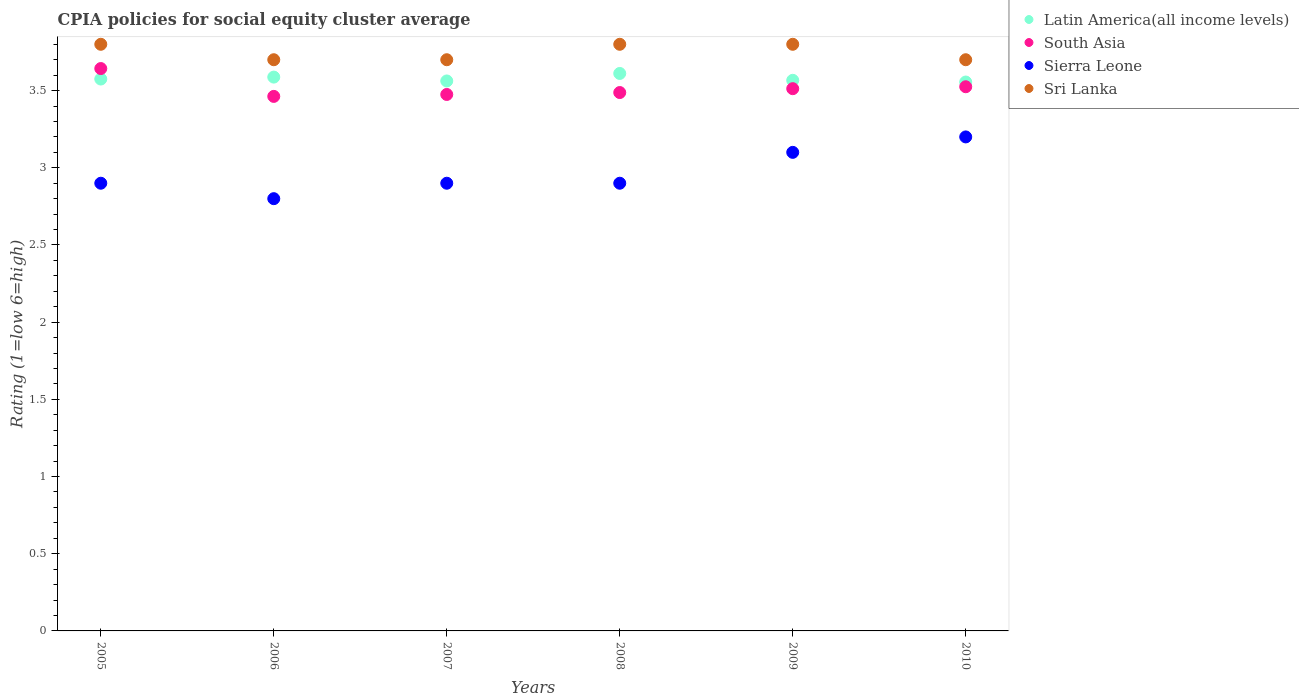How many different coloured dotlines are there?
Provide a succinct answer. 4. Is the number of dotlines equal to the number of legend labels?
Your response must be concise. Yes. What is the CPIA rating in Latin America(all income levels) in 2009?
Make the answer very short. 3.57. Across all years, what is the maximum CPIA rating in South Asia?
Provide a short and direct response. 3.64. Across all years, what is the minimum CPIA rating in Sierra Leone?
Provide a succinct answer. 2.8. In which year was the CPIA rating in South Asia minimum?
Provide a short and direct response. 2006. What is the difference between the CPIA rating in Latin America(all income levels) in 2007 and that in 2010?
Give a very brief answer. 0.01. What is the difference between the CPIA rating in South Asia in 2007 and the CPIA rating in Latin America(all income levels) in 2008?
Ensure brevity in your answer.  -0.14. What is the average CPIA rating in South Asia per year?
Keep it short and to the point. 3.52. In the year 2009, what is the difference between the CPIA rating in South Asia and CPIA rating in Latin America(all income levels)?
Your answer should be compact. -0.05. In how many years, is the CPIA rating in Sri Lanka greater than 2.4?
Give a very brief answer. 6. What is the ratio of the CPIA rating in Sri Lanka in 2006 to that in 2009?
Provide a succinct answer. 0.97. What is the difference between the highest and the second highest CPIA rating in Latin America(all income levels)?
Offer a very short reply. 0.02. What is the difference between the highest and the lowest CPIA rating in Sri Lanka?
Provide a short and direct response. 0.1. Is the sum of the CPIA rating in South Asia in 2006 and 2009 greater than the maximum CPIA rating in Latin America(all income levels) across all years?
Your response must be concise. Yes. Is it the case that in every year, the sum of the CPIA rating in Latin America(all income levels) and CPIA rating in Sierra Leone  is greater than the sum of CPIA rating in Sri Lanka and CPIA rating in South Asia?
Give a very brief answer. No. Is it the case that in every year, the sum of the CPIA rating in Latin America(all income levels) and CPIA rating in South Asia  is greater than the CPIA rating in Sierra Leone?
Your answer should be compact. Yes. Is the CPIA rating in South Asia strictly greater than the CPIA rating in Sierra Leone over the years?
Offer a very short reply. Yes. Is the CPIA rating in Sri Lanka strictly less than the CPIA rating in Sierra Leone over the years?
Make the answer very short. No. How many years are there in the graph?
Ensure brevity in your answer.  6. Does the graph contain any zero values?
Provide a succinct answer. No. Does the graph contain grids?
Ensure brevity in your answer.  No. How are the legend labels stacked?
Provide a short and direct response. Vertical. What is the title of the graph?
Make the answer very short. CPIA policies for social equity cluster average. Does "Libya" appear as one of the legend labels in the graph?
Offer a terse response. No. What is the label or title of the X-axis?
Offer a terse response. Years. What is the label or title of the Y-axis?
Provide a succinct answer. Rating (1=low 6=high). What is the Rating (1=low 6=high) of Latin America(all income levels) in 2005?
Make the answer very short. 3.58. What is the Rating (1=low 6=high) of South Asia in 2005?
Offer a very short reply. 3.64. What is the Rating (1=low 6=high) of Sri Lanka in 2005?
Your answer should be compact. 3.8. What is the Rating (1=low 6=high) of Latin America(all income levels) in 2006?
Give a very brief answer. 3.59. What is the Rating (1=low 6=high) in South Asia in 2006?
Ensure brevity in your answer.  3.46. What is the Rating (1=low 6=high) in Sri Lanka in 2006?
Provide a short and direct response. 3.7. What is the Rating (1=low 6=high) of Latin America(all income levels) in 2007?
Offer a very short reply. 3.56. What is the Rating (1=low 6=high) of South Asia in 2007?
Your answer should be very brief. 3.48. What is the Rating (1=low 6=high) of Sierra Leone in 2007?
Make the answer very short. 2.9. What is the Rating (1=low 6=high) of Latin America(all income levels) in 2008?
Keep it short and to the point. 3.61. What is the Rating (1=low 6=high) of South Asia in 2008?
Make the answer very short. 3.49. What is the Rating (1=low 6=high) in Sierra Leone in 2008?
Offer a very short reply. 2.9. What is the Rating (1=low 6=high) of Sri Lanka in 2008?
Make the answer very short. 3.8. What is the Rating (1=low 6=high) in Latin America(all income levels) in 2009?
Your answer should be compact. 3.57. What is the Rating (1=low 6=high) in South Asia in 2009?
Your answer should be compact. 3.51. What is the Rating (1=low 6=high) of Sierra Leone in 2009?
Your answer should be compact. 3.1. What is the Rating (1=low 6=high) in Sri Lanka in 2009?
Your answer should be compact. 3.8. What is the Rating (1=low 6=high) of Latin America(all income levels) in 2010?
Give a very brief answer. 3.56. What is the Rating (1=low 6=high) of South Asia in 2010?
Provide a short and direct response. 3.52. What is the Rating (1=low 6=high) of Sri Lanka in 2010?
Provide a short and direct response. 3.7. Across all years, what is the maximum Rating (1=low 6=high) of Latin America(all income levels)?
Give a very brief answer. 3.61. Across all years, what is the maximum Rating (1=low 6=high) of South Asia?
Offer a very short reply. 3.64. Across all years, what is the minimum Rating (1=low 6=high) of Latin America(all income levels)?
Provide a short and direct response. 3.56. Across all years, what is the minimum Rating (1=low 6=high) of South Asia?
Your answer should be very brief. 3.46. Across all years, what is the minimum Rating (1=low 6=high) in Sierra Leone?
Provide a short and direct response. 2.8. What is the total Rating (1=low 6=high) in Latin America(all income levels) in the graph?
Keep it short and to the point. 21.46. What is the total Rating (1=low 6=high) in South Asia in the graph?
Make the answer very short. 21.11. What is the total Rating (1=low 6=high) in Sri Lanka in the graph?
Keep it short and to the point. 22.5. What is the difference between the Rating (1=low 6=high) of Latin America(all income levels) in 2005 and that in 2006?
Provide a succinct answer. -0.01. What is the difference between the Rating (1=low 6=high) in South Asia in 2005 and that in 2006?
Make the answer very short. 0.18. What is the difference between the Rating (1=low 6=high) in Sri Lanka in 2005 and that in 2006?
Offer a terse response. 0.1. What is the difference between the Rating (1=low 6=high) of Latin America(all income levels) in 2005 and that in 2007?
Offer a terse response. 0.01. What is the difference between the Rating (1=low 6=high) in South Asia in 2005 and that in 2007?
Provide a short and direct response. 0.17. What is the difference between the Rating (1=low 6=high) in Sierra Leone in 2005 and that in 2007?
Offer a terse response. 0. What is the difference between the Rating (1=low 6=high) in Latin America(all income levels) in 2005 and that in 2008?
Your answer should be very brief. -0.04. What is the difference between the Rating (1=low 6=high) of South Asia in 2005 and that in 2008?
Give a very brief answer. 0.16. What is the difference between the Rating (1=low 6=high) in Sierra Leone in 2005 and that in 2008?
Provide a short and direct response. 0. What is the difference between the Rating (1=low 6=high) of Latin America(all income levels) in 2005 and that in 2009?
Offer a very short reply. 0.01. What is the difference between the Rating (1=low 6=high) of South Asia in 2005 and that in 2009?
Offer a terse response. 0.13. What is the difference between the Rating (1=low 6=high) in Latin America(all income levels) in 2005 and that in 2010?
Give a very brief answer. 0.02. What is the difference between the Rating (1=low 6=high) of South Asia in 2005 and that in 2010?
Make the answer very short. 0.12. What is the difference between the Rating (1=low 6=high) in Sri Lanka in 2005 and that in 2010?
Make the answer very short. 0.1. What is the difference between the Rating (1=low 6=high) of Latin America(all income levels) in 2006 and that in 2007?
Offer a terse response. 0.03. What is the difference between the Rating (1=low 6=high) of South Asia in 2006 and that in 2007?
Ensure brevity in your answer.  -0.01. What is the difference between the Rating (1=low 6=high) in Latin America(all income levels) in 2006 and that in 2008?
Provide a short and direct response. -0.02. What is the difference between the Rating (1=low 6=high) in South Asia in 2006 and that in 2008?
Give a very brief answer. -0.03. What is the difference between the Rating (1=low 6=high) in Sierra Leone in 2006 and that in 2008?
Give a very brief answer. -0.1. What is the difference between the Rating (1=low 6=high) of Sri Lanka in 2006 and that in 2008?
Ensure brevity in your answer.  -0.1. What is the difference between the Rating (1=low 6=high) in Latin America(all income levels) in 2006 and that in 2009?
Offer a very short reply. 0.02. What is the difference between the Rating (1=low 6=high) in Sierra Leone in 2006 and that in 2009?
Offer a very short reply. -0.3. What is the difference between the Rating (1=low 6=high) in Latin America(all income levels) in 2006 and that in 2010?
Your answer should be very brief. 0.03. What is the difference between the Rating (1=low 6=high) in South Asia in 2006 and that in 2010?
Ensure brevity in your answer.  -0.06. What is the difference between the Rating (1=low 6=high) of Sierra Leone in 2006 and that in 2010?
Offer a very short reply. -0.4. What is the difference between the Rating (1=low 6=high) in Sri Lanka in 2006 and that in 2010?
Make the answer very short. 0. What is the difference between the Rating (1=low 6=high) in Latin America(all income levels) in 2007 and that in 2008?
Ensure brevity in your answer.  -0.05. What is the difference between the Rating (1=low 6=high) of South Asia in 2007 and that in 2008?
Your response must be concise. -0.01. What is the difference between the Rating (1=low 6=high) in Sierra Leone in 2007 and that in 2008?
Make the answer very short. 0. What is the difference between the Rating (1=low 6=high) in Latin America(all income levels) in 2007 and that in 2009?
Provide a succinct answer. -0. What is the difference between the Rating (1=low 6=high) of South Asia in 2007 and that in 2009?
Your answer should be very brief. -0.04. What is the difference between the Rating (1=low 6=high) of Latin America(all income levels) in 2007 and that in 2010?
Keep it short and to the point. 0.01. What is the difference between the Rating (1=low 6=high) in Latin America(all income levels) in 2008 and that in 2009?
Your answer should be compact. 0.04. What is the difference between the Rating (1=low 6=high) of South Asia in 2008 and that in 2009?
Keep it short and to the point. -0.03. What is the difference between the Rating (1=low 6=high) of Latin America(all income levels) in 2008 and that in 2010?
Your answer should be very brief. 0.06. What is the difference between the Rating (1=low 6=high) in South Asia in 2008 and that in 2010?
Provide a succinct answer. -0.04. What is the difference between the Rating (1=low 6=high) of Sierra Leone in 2008 and that in 2010?
Your answer should be compact. -0.3. What is the difference between the Rating (1=low 6=high) of Latin America(all income levels) in 2009 and that in 2010?
Offer a terse response. 0.01. What is the difference between the Rating (1=low 6=high) in South Asia in 2009 and that in 2010?
Ensure brevity in your answer.  -0.01. What is the difference between the Rating (1=low 6=high) of Sierra Leone in 2009 and that in 2010?
Offer a very short reply. -0.1. What is the difference between the Rating (1=low 6=high) in Latin America(all income levels) in 2005 and the Rating (1=low 6=high) in South Asia in 2006?
Make the answer very short. 0.11. What is the difference between the Rating (1=low 6=high) in Latin America(all income levels) in 2005 and the Rating (1=low 6=high) in Sierra Leone in 2006?
Your answer should be very brief. 0.78. What is the difference between the Rating (1=low 6=high) of Latin America(all income levels) in 2005 and the Rating (1=low 6=high) of Sri Lanka in 2006?
Offer a very short reply. -0.12. What is the difference between the Rating (1=low 6=high) in South Asia in 2005 and the Rating (1=low 6=high) in Sierra Leone in 2006?
Offer a very short reply. 0.84. What is the difference between the Rating (1=low 6=high) of South Asia in 2005 and the Rating (1=low 6=high) of Sri Lanka in 2006?
Your answer should be very brief. -0.06. What is the difference between the Rating (1=low 6=high) in Latin America(all income levels) in 2005 and the Rating (1=low 6=high) in South Asia in 2007?
Provide a succinct answer. 0.1. What is the difference between the Rating (1=low 6=high) of Latin America(all income levels) in 2005 and the Rating (1=low 6=high) of Sierra Leone in 2007?
Your answer should be very brief. 0.68. What is the difference between the Rating (1=low 6=high) of Latin America(all income levels) in 2005 and the Rating (1=low 6=high) of Sri Lanka in 2007?
Give a very brief answer. -0.12. What is the difference between the Rating (1=low 6=high) of South Asia in 2005 and the Rating (1=low 6=high) of Sierra Leone in 2007?
Make the answer very short. 0.74. What is the difference between the Rating (1=low 6=high) in South Asia in 2005 and the Rating (1=low 6=high) in Sri Lanka in 2007?
Provide a short and direct response. -0.06. What is the difference between the Rating (1=low 6=high) in Sierra Leone in 2005 and the Rating (1=low 6=high) in Sri Lanka in 2007?
Offer a very short reply. -0.8. What is the difference between the Rating (1=low 6=high) in Latin America(all income levels) in 2005 and the Rating (1=low 6=high) in South Asia in 2008?
Offer a very short reply. 0.09. What is the difference between the Rating (1=low 6=high) of Latin America(all income levels) in 2005 and the Rating (1=low 6=high) of Sierra Leone in 2008?
Keep it short and to the point. 0.68. What is the difference between the Rating (1=low 6=high) of Latin America(all income levels) in 2005 and the Rating (1=low 6=high) of Sri Lanka in 2008?
Make the answer very short. -0.23. What is the difference between the Rating (1=low 6=high) of South Asia in 2005 and the Rating (1=low 6=high) of Sierra Leone in 2008?
Offer a terse response. 0.74. What is the difference between the Rating (1=low 6=high) in South Asia in 2005 and the Rating (1=low 6=high) in Sri Lanka in 2008?
Your answer should be compact. -0.16. What is the difference between the Rating (1=low 6=high) in Latin America(all income levels) in 2005 and the Rating (1=low 6=high) in South Asia in 2009?
Your answer should be very brief. 0.06. What is the difference between the Rating (1=low 6=high) of Latin America(all income levels) in 2005 and the Rating (1=low 6=high) of Sierra Leone in 2009?
Make the answer very short. 0.47. What is the difference between the Rating (1=low 6=high) in Latin America(all income levels) in 2005 and the Rating (1=low 6=high) in Sri Lanka in 2009?
Provide a succinct answer. -0.23. What is the difference between the Rating (1=low 6=high) in South Asia in 2005 and the Rating (1=low 6=high) in Sierra Leone in 2009?
Keep it short and to the point. 0.54. What is the difference between the Rating (1=low 6=high) of South Asia in 2005 and the Rating (1=low 6=high) of Sri Lanka in 2009?
Keep it short and to the point. -0.16. What is the difference between the Rating (1=low 6=high) of Latin America(all income levels) in 2005 and the Rating (1=low 6=high) of South Asia in 2010?
Your answer should be very brief. 0.05. What is the difference between the Rating (1=low 6=high) in Latin America(all income levels) in 2005 and the Rating (1=low 6=high) in Sierra Leone in 2010?
Offer a very short reply. 0.38. What is the difference between the Rating (1=low 6=high) in Latin America(all income levels) in 2005 and the Rating (1=low 6=high) in Sri Lanka in 2010?
Offer a very short reply. -0.12. What is the difference between the Rating (1=low 6=high) of South Asia in 2005 and the Rating (1=low 6=high) of Sierra Leone in 2010?
Offer a very short reply. 0.44. What is the difference between the Rating (1=low 6=high) of South Asia in 2005 and the Rating (1=low 6=high) of Sri Lanka in 2010?
Your answer should be compact. -0.06. What is the difference between the Rating (1=low 6=high) of Sierra Leone in 2005 and the Rating (1=low 6=high) of Sri Lanka in 2010?
Give a very brief answer. -0.8. What is the difference between the Rating (1=low 6=high) of Latin America(all income levels) in 2006 and the Rating (1=low 6=high) of South Asia in 2007?
Your answer should be compact. 0.11. What is the difference between the Rating (1=low 6=high) of Latin America(all income levels) in 2006 and the Rating (1=low 6=high) of Sierra Leone in 2007?
Your answer should be very brief. 0.69. What is the difference between the Rating (1=low 6=high) of Latin America(all income levels) in 2006 and the Rating (1=low 6=high) of Sri Lanka in 2007?
Offer a very short reply. -0.11. What is the difference between the Rating (1=low 6=high) in South Asia in 2006 and the Rating (1=low 6=high) in Sierra Leone in 2007?
Your answer should be compact. 0.56. What is the difference between the Rating (1=low 6=high) of South Asia in 2006 and the Rating (1=low 6=high) of Sri Lanka in 2007?
Keep it short and to the point. -0.24. What is the difference between the Rating (1=low 6=high) in Sierra Leone in 2006 and the Rating (1=low 6=high) in Sri Lanka in 2007?
Give a very brief answer. -0.9. What is the difference between the Rating (1=low 6=high) in Latin America(all income levels) in 2006 and the Rating (1=low 6=high) in South Asia in 2008?
Ensure brevity in your answer.  0.1. What is the difference between the Rating (1=low 6=high) in Latin America(all income levels) in 2006 and the Rating (1=low 6=high) in Sierra Leone in 2008?
Give a very brief answer. 0.69. What is the difference between the Rating (1=low 6=high) of Latin America(all income levels) in 2006 and the Rating (1=low 6=high) of Sri Lanka in 2008?
Offer a terse response. -0.21. What is the difference between the Rating (1=low 6=high) of South Asia in 2006 and the Rating (1=low 6=high) of Sierra Leone in 2008?
Make the answer very short. 0.56. What is the difference between the Rating (1=low 6=high) in South Asia in 2006 and the Rating (1=low 6=high) in Sri Lanka in 2008?
Provide a short and direct response. -0.34. What is the difference between the Rating (1=low 6=high) in Sierra Leone in 2006 and the Rating (1=low 6=high) in Sri Lanka in 2008?
Your answer should be compact. -1. What is the difference between the Rating (1=low 6=high) in Latin America(all income levels) in 2006 and the Rating (1=low 6=high) in South Asia in 2009?
Your answer should be very brief. 0.07. What is the difference between the Rating (1=low 6=high) of Latin America(all income levels) in 2006 and the Rating (1=low 6=high) of Sierra Leone in 2009?
Provide a succinct answer. 0.49. What is the difference between the Rating (1=low 6=high) in Latin America(all income levels) in 2006 and the Rating (1=low 6=high) in Sri Lanka in 2009?
Give a very brief answer. -0.21. What is the difference between the Rating (1=low 6=high) of South Asia in 2006 and the Rating (1=low 6=high) of Sierra Leone in 2009?
Your answer should be very brief. 0.36. What is the difference between the Rating (1=low 6=high) in South Asia in 2006 and the Rating (1=low 6=high) in Sri Lanka in 2009?
Provide a short and direct response. -0.34. What is the difference between the Rating (1=low 6=high) of Sierra Leone in 2006 and the Rating (1=low 6=high) of Sri Lanka in 2009?
Your response must be concise. -1. What is the difference between the Rating (1=low 6=high) in Latin America(all income levels) in 2006 and the Rating (1=low 6=high) in South Asia in 2010?
Your response must be concise. 0.06. What is the difference between the Rating (1=low 6=high) in Latin America(all income levels) in 2006 and the Rating (1=low 6=high) in Sierra Leone in 2010?
Offer a very short reply. 0.39. What is the difference between the Rating (1=low 6=high) of Latin America(all income levels) in 2006 and the Rating (1=low 6=high) of Sri Lanka in 2010?
Your answer should be very brief. -0.11. What is the difference between the Rating (1=low 6=high) of South Asia in 2006 and the Rating (1=low 6=high) of Sierra Leone in 2010?
Give a very brief answer. 0.26. What is the difference between the Rating (1=low 6=high) of South Asia in 2006 and the Rating (1=low 6=high) of Sri Lanka in 2010?
Your response must be concise. -0.24. What is the difference between the Rating (1=low 6=high) in Latin America(all income levels) in 2007 and the Rating (1=low 6=high) in South Asia in 2008?
Offer a terse response. 0.07. What is the difference between the Rating (1=low 6=high) of Latin America(all income levels) in 2007 and the Rating (1=low 6=high) of Sierra Leone in 2008?
Your answer should be very brief. 0.66. What is the difference between the Rating (1=low 6=high) of Latin America(all income levels) in 2007 and the Rating (1=low 6=high) of Sri Lanka in 2008?
Your response must be concise. -0.24. What is the difference between the Rating (1=low 6=high) in South Asia in 2007 and the Rating (1=low 6=high) in Sierra Leone in 2008?
Offer a terse response. 0.57. What is the difference between the Rating (1=low 6=high) of South Asia in 2007 and the Rating (1=low 6=high) of Sri Lanka in 2008?
Ensure brevity in your answer.  -0.33. What is the difference between the Rating (1=low 6=high) of Sierra Leone in 2007 and the Rating (1=low 6=high) of Sri Lanka in 2008?
Ensure brevity in your answer.  -0.9. What is the difference between the Rating (1=low 6=high) of Latin America(all income levels) in 2007 and the Rating (1=low 6=high) of South Asia in 2009?
Offer a terse response. 0.05. What is the difference between the Rating (1=low 6=high) in Latin America(all income levels) in 2007 and the Rating (1=low 6=high) in Sierra Leone in 2009?
Your answer should be compact. 0.46. What is the difference between the Rating (1=low 6=high) in Latin America(all income levels) in 2007 and the Rating (1=low 6=high) in Sri Lanka in 2009?
Provide a short and direct response. -0.24. What is the difference between the Rating (1=low 6=high) in South Asia in 2007 and the Rating (1=low 6=high) in Sierra Leone in 2009?
Ensure brevity in your answer.  0.38. What is the difference between the Rating (1=low 6=high) in South Asia in 2007 and the Rating (1=low 6=high) in Sri Lanka in 2009?
Provide a succinct answer. -0.33. What is the difference between the Rating (1=low 6=high) in Sierra Leone in 2007 and the Rating (1=low 6=high) in Sri Lanka in 2009?
Make the answer very short. -0.9. What is the difference between the Rating (1=low 6=high) of Latin America(all income levels) in 2007 and the Rating (1=low 6=high) of South Asia in 2010?
Provide a short and direct response. 0.04. What is the difference between the Rating (1=low 6=high) of Latin America(all income levels) in 2007 and the Rating (1=low 6=high) of Sierra Leone in 2010?
Your response must be concise. 0.36. What is the difference between the Rating (1=low 6=high) in Latin America(all income levels) in 2007 and the Rating (1=low 6=high) in Sri Lanka in 2010?
Ensure brevity in your answer.  -0.14. What is the difference between the Rating (1=low 6=high) in South Asia in 2007 and the Rating (1=low 6=high) in Sierra Leone in 2010?
Your answer should be compact. 0.28. What is the difference between the Rating (1=low 6=high) of South Asia in 2007 and the Rating (1=low 6=high) of Sri Lanka in 2010?
Provide a short and direct response. -0.23. What is the difference between the Rating (1=low 6=high) of Sierra Leone in 2007 and the Rating (1=low 6=high) of Sri Lanka in 2010?
Give a very brief answer. -0.8. What is the difference between the Rating (1=low 6=high) in Latin America(all income levels) in 2008 and the Rating (1=low 6=high) in South Asia in 2009?
Give a very brief answer. 0.1. What is the difference between the Rating (1=low 6=high) in Latin America(all income levels) in 2008 and the Rating (1=low 6=high) in Sierra Leone in 2009?
Offer a terse response. 0.51. What is the difference between the Rating (1=low 6=high) of Latin America(all income levels) in 2008 and the Rating (1=low 6=high) of Sri Lanka in 2009?
Ensure brevity in your answer.  -0.19. What is the difference between the Rating (1=low 6=high) of South Asia in 2008 and the Rating (1=low 6=high) of Sierra Leone in 2009?
Your answer should be very brief. 0.39. What is the difference between the Rating (1=low 6=high) of South Asia in 2008 and the Rating (1=low 6=high) of Sri Lanka in 2009?
Your answer should be compact. -0.31. What is the difference between the Rating (1=low 6=high) of Sierra Leone in 2008 and the Rating (1=low 6=high) of Sri Lanka in 2009?
Ensure brevity in your answer.  -0.9. What is the difference between the Rating (1=low 6=high) of Latin America(all income levels) in 2008 and the Rating (1=low 6=high) of South Asia in 2010?
Your answer should be very brief. 0.09. What is the difference between the Rating (1=low 6=high) in Latin America(all income levels) in 2008 and the Rating (1=low 6=high) in Sierra Leone in 2010?
Give a very brief answer. 0.41. What is the difference between the Rating (1=low 6=high) of Latin America(all income levels) in 2008 and the Rating (1=low 6=high) of Sri Lanka in 2010?
Your answer should be compact. -0.09. What is the difference between the Rating (1=low 6=high) in South Asia in 2008 and the Rating (1=low 6=high) in Sierra Leone in 2010?
Your answer should be very brief. 0.29. What is the difference between the Rating (1=low 6=high) in South Asia in 2008 and the Rating (1=low 6=high) in Sri Lanka in 2010?
Offer a very short reply. -0.21. What is the difference between the Rating (1=low 6=high) of Latin America(all income levels) in 2009 and the Rating (1=low 6=high) of South Asia in 2010?
Your response must be concise. 0.04. What is the difference between the Rating (1=low 6=high) of Latin America(all income levels) in 2009 and the Rating (1=low 6=high) of Sierra Leone in 2010?
Offer a very short reply. 0.37. What is the difference between the Rating (1=low 6=high) of Latin America(all income levels) in 2009 and the Rating (1=low 6=high) of Sri Lanka in 2010?
Offer a terse response. -0.13. What is the difference between the Rating (1=low 6=high) in South Asia in 2009 and the Rating (1=low 6=high) in Sierra Leone in 2010?
Give a very brief answer. 0.31. What is the difference between the Rating (1=low 6=high) of South Asia in 2009 and the Rating (1=low 6=high) of Sri Lanka in 2010?
Ensure brevity in your answer.  -0.19. What is the average Rating (1=low 6=high) of Latin America(all income levels) per year?
Offer a very short reply. 3.58. What is the average Rating (1=low 6=high) of South Asia per year?
Keep it short and to the point. 3.52. What is the average Rating (1=low 6=high) in Sierra Leone per year?
Provide a short and direct response. 2.97. What is the average Rating (1=low 6=high) in Sri Lanka per year?
Make the answer very short. 3.75. In the year 2005, what is the difference between the Rating (1=low 6=high) of Latin America(all income levels) and Rating (1=low 6=high) of South Asia?
Give a very brief answer. -0.07. In the year 2005, what is the difference between the Rating (1=low 6=high) of Latin America(all income levels) and Rating (1=low 6=high) of Sierra Leone?
Your answer should be very brief. 0.68. In the year 2005, what is the difference between the Rating (1=low 6=high) of Latin America(all income levels) and Rating (1=low 6=high) of Sri Lanka?
Keep it short and to the point. -0.23. In the year 2005, what is the difference between the Rating (1=low 6=high) of South Asia and Rating (1=low 6=high) of Sierra Leone?
Your response must be concise. 0.74. In the year 2005, what is the difference between the Rating (1=low 6=high) of South Asia and Rating (1=low 6=high) of Sri Lanka?
Provide a succinct answer. -0.16. In the year 2006, what is the difference between the Rating (1=low 6=high) in Latin America(all income levels) and Rating (1=low 6=high) in South Asia?
Give a very brief answer. 0.12. In the year 2006, what is the difference between the Rating (1=low 6=high) in Latin America(all income levels) and Rating (1=low 6=high) in Sierra Leone?
Make the answer very short. 0.79. In the year 2006, what is the difference between the Rating (1=low 6=high) of Latin America(all income levels) and Rating (1=low 6=high) of Sri Lanka?
Offer a terse response. -0.11. In the year 2006, what is the difference between the Rating (1=low 6=high) in South Asia and Rating (1=low 6=high) in Sierra Leone?
Provide a short and direct response. 0.66. In the year 2006, what is the difference between the Rating (1=low 6=high) in South Asia and Rating (1=low 6=high) in Sri Lanka?
Your response must be concise. -0.24. In the year 2007, what is the difference between the Rating (1=low 6=high) in Latin America(all income levels) and Rating (1=low 6=high) in South Asia?
Keep it short and to the point. 0.09. In the year 2007, what is the difference between the Rating (1=low 6=high) of Latin America(all income levels) and Rating (1=low 6=high) of Sierra Leone?
Make the answer very short. 0.66. In the year 2007, what is the difference between the Rating (1=low 6=high) of Latin America(all income levels) and Rating (1=low 6=high) of Sri Lanka?
Provide a short and direct response. -0.14. In the year 2007, what is the difference between the Rating (1=low 6=high) of South Asia and Rating (1=low 6=high) of Sierra Leone?
Make the answer very short. 0.57. In the year 2007, what is the difference between the Rating (1=low 6=high) of South Asia and Rating (1=low 6=high) of Sri Lanka?
Your response must be concise. -0.23. In the year 2007, what is the difference between the Rating (1=low 6=high) of Sierra Leone and Rating (1=low 6=high) of Sri Lanka?
Offer a terse response. -0.8. In the year 2008, what is the difference between the Rating (1=low 6=high) of Latin America(all income levels) and Rating (1=low 6=high) of South Asia?
Offer a very short reply. 0.12. In the year 2008, what is the difference between the Rating (1=low 6=high) in Latin America(all income levels) and Rating (1=low 6=high) in Sierra Leone?
Your answer should be very brief. 0.71. In the year 2008, what is the difference between the Rating (1=low 6=high) of Latin America(all income levels) and Rating (1=low 6=high) of Sri Lanka?
Your response must be concise. -0.19. In the year 2008, what is the difference between the Rating (1=low 6=high) in South Asia and Rating (1=low 6=high) in Sierra Leone?
Keep it short and to the point. 0.59. In the year 2008, what is the difference between the Rating (1=low 6=high) of South Asia and Rating (1=low 6=high) of Sri Lanka?
Your response must be concise. -0.31. In the year 2008, what is the difference between the Rating (1=low 6=high) of Sierra Leone and Rating (1=low 6=high) of Sri Lanka?
Your answer should be compact. -0.9. In the year 2009, what is the difference between the Rating (1=low 6=high) of Latin America(all income levels) and Rating (1=low 6=high) of South Asia?
Offer a terse response. 0.05. In the year 2009, what is the difference between the Rating (1=low 6=high) of Latin America(all income levels) and Rating (1=low 6=high) of Sierra Leone?
Offer a very short reply. 0.47. In the year 2009, what is the difference between the Rating (1=low 6=high) of Latin America(all income levels) and Rating (1=low 6=high) of Sri Lanka?
Offer a very short reply. -0.23. In the year 2009, what is the difference between the Rating (1=low 6=high) of South Asia and Rating (1=low 6=high) of Sierra Leone?
Give a very brief answer. 0.41. In the year 2009, what is the difference between the Rating (1=low 6=high) of South Asia and Rating (1=low 6=high) of Sri Lanka?
Give a very brief answer. -0.29. In the year 2010, what is the difference between the Rating (1=low 6=high) of Latin America(all income levels) and Rating (1=low 6=high) of South Asia?
Keep it short and to the point. 0.03. In the year 2010, what is the difference between the Rating (1=low 6=high) of Latin America(all income levels) and Rating (1=low 6=high) of Sierra Leone?
Offer a very short reply. 0.36. In the year 2010, what is the difference between the Rating (1=low 6=high) of Latin America(all income levels) and Rating (1=low 6=high) of Sri Lanka?
Offer a very short reply. -0.14. In the year 2010, what is the difference between the Rating (1=low 6=high) in South Asia and Rating (1=low 6=high) in Sierra Leone?
Offer a very short reply. 0.33. In the year 2010, what is the difference between the Rating (1=low 6=high) of South Asia and Rating (1=low 6=high) of Sri Lanka?
Offer a terse response. -0.17. What is the ratio of the Rating (1=low 6=high) in South Asia in 2005 to that in 2006?
Ensure brevity in your answer.  1.05. What is the ratio of the Rating (1=low 6=high) of Sierra Leone in 2005 to that in 2006?
Keep it short and to the point. 1.04. What is the ratio of the Rating (1=low 6=high) of South Asia in 2005 to that in 2007?
Your answer should be compact. 1.05. What is the ratio of the Rating (1=low 6=high) of South Asia in 2005 to that in 2008?
Your answer should be compact. 1.04. What is the ratio of the Rating (1=low 6=high) of Sierra Leone in 2005 to that in 2008?
Make the answer very short. 1. What is the ratio of the Rating (1=low 6=high) of Sri Lanka in 2005 to that in 2008?
Your response must be concise. 1. What is the ratio of the Rating (1=low 6=high) in South Asia in 2005 to that in 2009?
Provide a short and direct response. 1.04. What is the ratio of the Rating (1=low 6=high) of Sierra Leone in 2005 to that in 2009?
Your answer should be very brief. 0.94. What is the ratio of the Rating (1=low 6=high) of South Asia in 2005 to that in 2010?
Ensure brevity in your answer.  1.03. What is the ratio of the Rating (1=low 6=high) of Sierra Leone in 2005 to that in 2010?
Offer a very short reply. 0.91. What is the ratio of the Rating (1=low 6=high) of South Asia in 2006 to that in 2007?
Give a very brief answer. 1. What is the ratio of the Rating (1=low 6=high) in Sierra Leone in 2006 to that in 2007?
Keep it short and to the point. 0.97. What is the ratio of the Rating (1=low 6=high) of Sri Lanka in 2006 to that in 2007?
Ensure brevity in your answer.  1. What is the ratio of the Rating (1=low 6=high) in Latin America(all income levels) in 2006 to that in 2008?
Make the answer very short. 0.99. What is the ratio of the Rating (1=low 6=high) of South Asia in 2006 to that in 2008?
Make the answer very short. 0.99. What is the ratio of the Rating (1=low 6=high) of Sierra Leone in 2006 to that in 2008?
Your answer should be very brief. 0.97. What is the ratio of the Rating (1=low 6=high) in Sri Lanka in 2006 to that in 2008?
Your answer should be very brief. 0.97. What is the ratio of the Rating (1=low 6=high) in South Asia in 2006 to that in 2009?
Your answer should be very brief. 0.99. What is the ratio of the Rating (1=low 6=high) in Sierra Leone in 2006 to that in 2009?
Keep it short and to the point. 0.9. What is the ratio of the Rating (1=low 6=high) in Sri Lanka in 2006 to that in 2009?
Your response must be concise. 0.97. What is the ratio of the Rating (1=low 6=high) of Latin America(all income levels) in 2006 to that in 2010?
Your response must be concise. 1.01. What is the ratio of the Rating (1=low 6=high) of South Asia in 2006 to that in 2010?
Your answer should be compact. 0.98. What is the ratio of the Rating (1=low 6=high) in Sierra Leone in 2006 to that in 2010?
Provide a short and direct response. 0.88. What is the ratio of the Rating (1=low 6=high) in Sri Lanka in 2006 to that in 2010?
Make the answer very short. 1. What is the ratio of the Rating (1=low 6=high) in Latin America(all income levels) in 2007 to that in 2008?
Provide a short and direct response. 0.99. What is the ratio of the Rating (1=low 6=high) in South Asia in 2007 to that in 2008?
Offer a very short reply. 1. What is the ratio of the Rating (1=low 6=high) in Sierra Leone in 2007 to that in 2008?
Your answer should be compact. 1. What is the ratio of the Rating (1=low 6=high) in Sri Lanka in 2007 to that in 2008?
Offer a very short reply. 0.97. What is the ratio of the Rating (1=low 6=high) in Latin America(all income levels) in 2007 to that in 2009?
Provide a short and direct response. 1. What is the ratio of the Rating (1=low 6=high) of South Asia in 2007 to that in 2009?
Your answer should be very brief. 0.99. What is the ratio of the Rating (1=low 6=high) of Sierra Leone in 2007 to that in 2009?
Keep it short and to the point. 0.94. What is the ratio of the Rating (1=low 6=high) of Sri Lanka in 2007 to that in 2009?
Your answer should be compact. 0.97. What is the ratio of the Rating (1=low 6=high) of South Asia in 2007 to that in 2010?
Ensure brevity in your answer.  0.99. What is the ratio of the Rating (1=low 6=high) in Sierra Leone in 2007 to that in 2010?
Ensure brevity in your answer.  0.91. What is the ratio of the Rating (1=low 6=high) of Sri Lanka in 2007 to that in 2010?
Give a very brief answer. 1. What is the ratio of the Rating (1=low 6=high) in Latin America(all income levels) in 2008 to that in 2009?
Your answer should be compact. 1.01. What is the ratio of the Rating (1=low 6=high) of Sierra Leone in 2008 to that in 2009?
Make the answer very short. 0.94. What is the ratio of the Rating (1=low 6=high) of Latin America(all income levels) in 2008 to that in 2010?
Your answer should be very brief. 1.02. What is the ratio of the Rating (1=low 6=high) of Sierra Leone in 2008 to that in 2010?
Give a very brief answer. 0.91. What is the ratio of the Rating (1=low 6=high) in Sierra Leone in 2009 to that in 2010?
Your answer should be compact. 0.97. What is the difference between the highest and the second highest Rating (1=low 6=high) of Latin America(all income levels)?
Offer a terse response. 0.02. What is the difference between the highest and the second highest Rating (1=low 6=high) of South Asia?
Your response must be concise. 0.12. What is the difference between the highest and the second highest Rating (1=low 6=high) in Sri Lanka?
Your response must be concise. 0. What is the difference between the highest and the lowest Rating (1=low 6=high) in Latin America(all income levels)?
Keep it short and to the point. 0.06. What is the difference between the highest and the lowest Rating (1=low 6=high) in South Asia?
Give a very brief answer. 0.18. What is the difference between the highest and the lowest Rating (1=low 6=high) in Sierra Leone?
Keep it short and to the point. 0.4. What is the difference between the highest and the lowest Rating (1=low 6=high) in Sri Lanka?
Give a very brief answer. 0.1. 